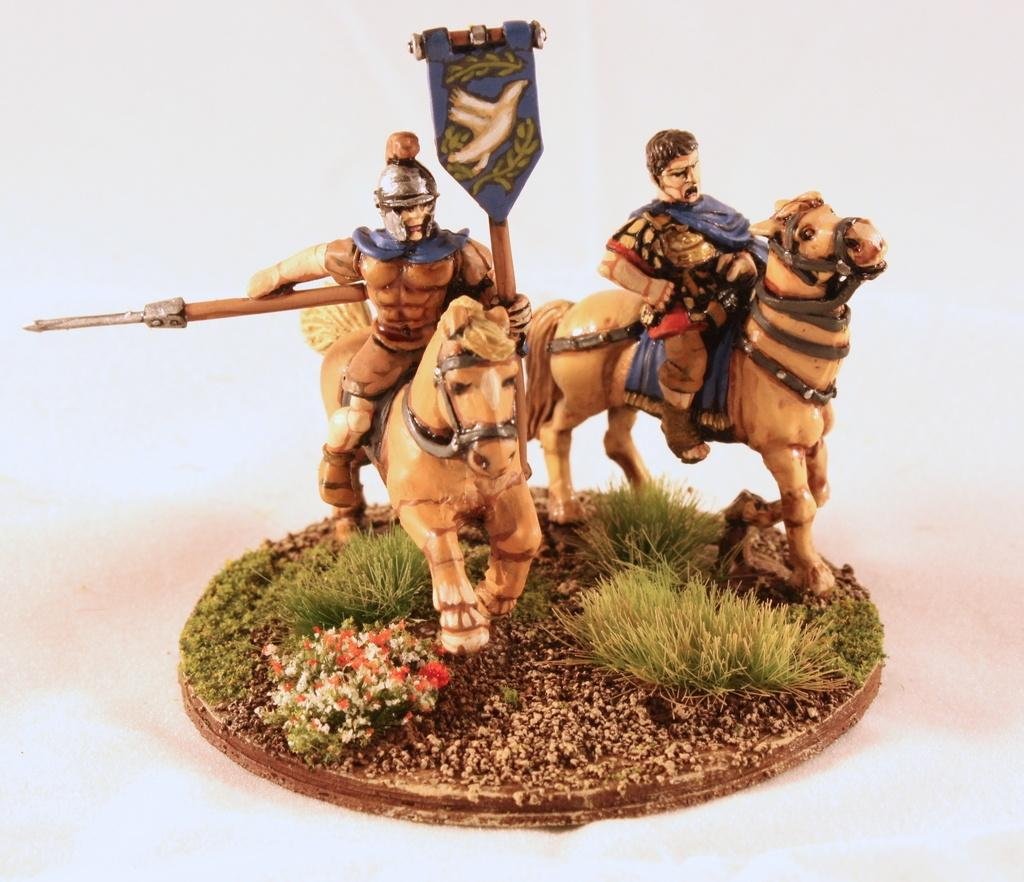What is the main subject in the image? There is a statue in the image. What can be seen in the background of the image? The background of the image is white. What type of operation is being performed on the floor in the image? There is no operation or any indication of an operation in the image; it features a statue with a white background. 